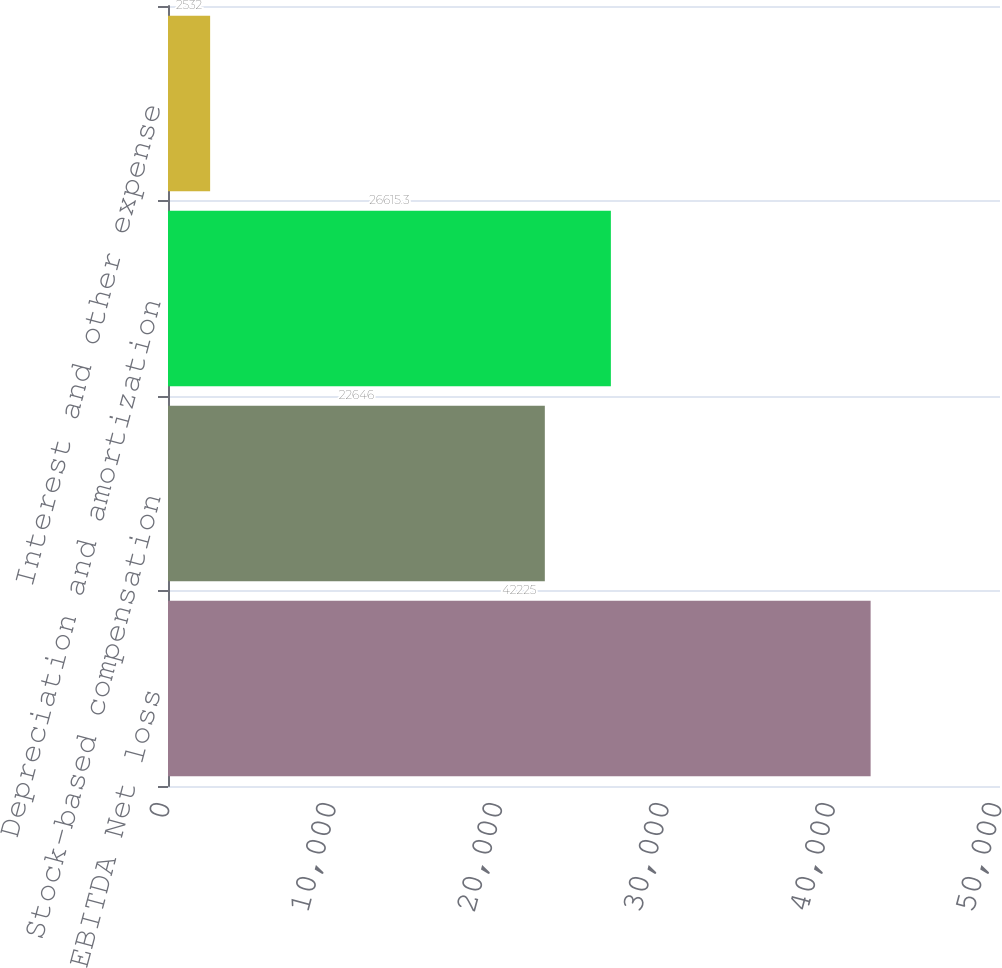<chart> <loc_0><loc_0><loc_500><loc_500><bar_chart><fcel>EBITDA Net loss<fcel>Stock-based compensation<fcel>Depreciation and amortization<fcel>Interest and other expense<nl><fcel>42225<fcel>22646<fcel>26615.3<fcel>2532<nl></chart> 